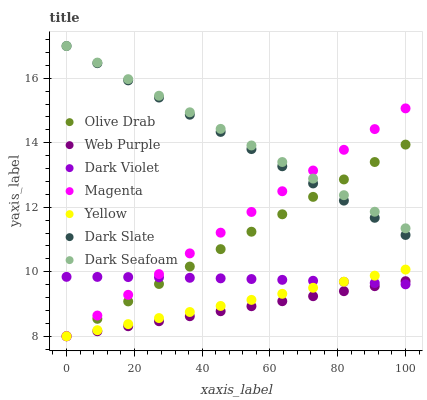Does Web Purple have the minimum area under the curve?
Answer yes or no. Yes. Does Dark Seafoam have the maximum area under the curve?
Answer yes or no. Yes. Does Yellow have the minimum area under the curve?
Answer yes or no. No. Does Yellow have the maximum area under the curve?
Answer yes or no. No. Is Yellow the smoothest?
Answer yes or no. Yes. Is Dark Violet the roughest?
Answer yes or no. Yes. Is Dark Slate the smoothest?
Answer yes or no. No. Is Dark Slate the roughest?
Answer yes or no. No. Does Yellow have the lowest value?
Answer yes or no. Yes. Does Dark Slate have the lowest value?
Answer yes or no. No. Does Dark Slate have the highest value?
Answer yes or no. Yes. Does Yellow have the highest value?
Answer yes or no. No. Is Web Purple less than Dark Slate?
Answer yes or no. Yes. Is Dark Seafoam greater than Yellow?
Answer yes or no. Yes. Does Dark Violet intersect Magenta?
Answer yes or no. Yes. Is Dark Violet less than Magenta?
Answer yes or no. No. Is Dark Violet greater than Magenta?
Answer yes or no. No. Does Web Purple intersect Dark Slate?
Answer yes or no. No. 